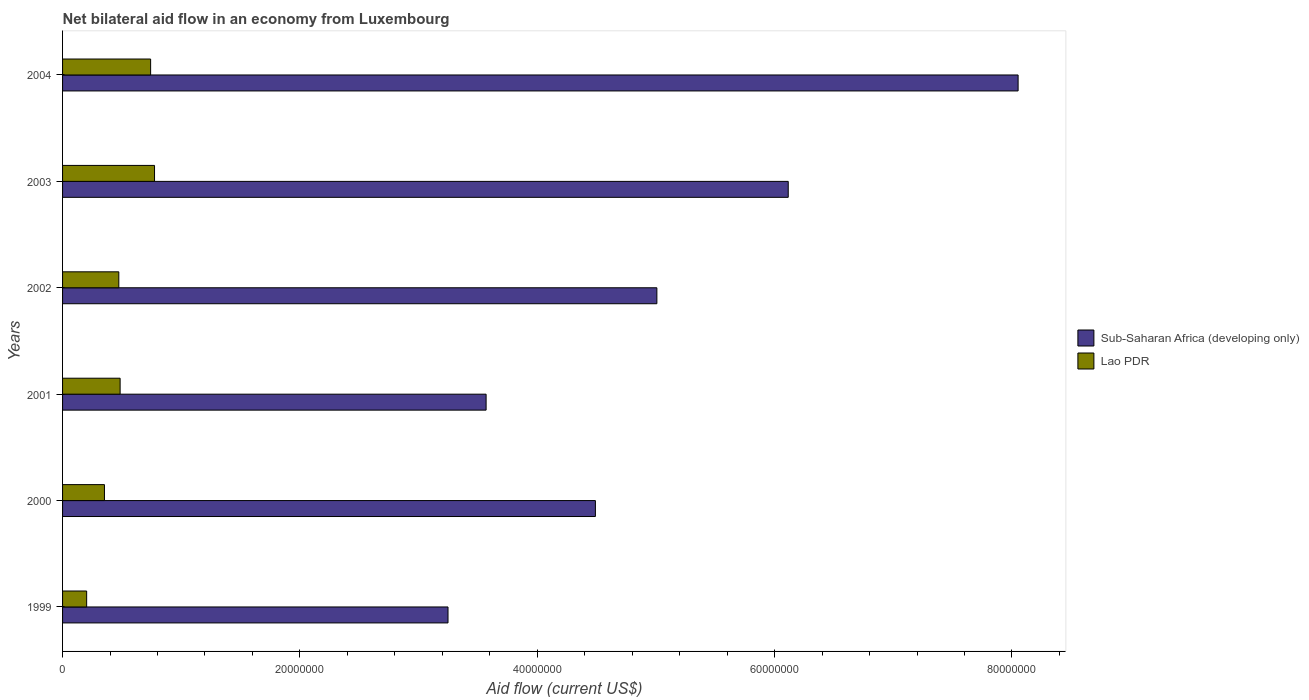How many different coloured bars are there?
Ensure brevity in your answer.  2. Are the number of bars on each tick of the Y-axis equal?
Make the answer very short. Yes. How many bars are there on the 3rd tick from the bottom?
Offer a very short reply. 2. What is the label of the 3rd group of bars from the top?
Your answer should be compact. 2002. In how many cases, is the number of bars for a given year not equal to the number of legend labels?
Provide a short and direct response. 0. What is the net bilateral aid flow in Sub-Saharan Africa (developing only) in 2001?
Keep it short and to the point. 3.57e+07. Across all years, what is the maximum net bilateral aid flow in Lao PDR?
Offer a very short reply. 7.75e+06. Across all years, what is the minimum net bilateral aid flow in Sub-Saharan Africa (developing only)?
Make the answer very short. 3.25e+07. What is the total net bilateral aid flow in Sub-Saharan Africa (developing only) in the graph?
Your answer should be very brief. 3.05e+08. What is the difference between the net bilateral aid flow in Sub-Saharan Africa (developing only) in 2000 and that in 2003?
Offer a terse response. -1.62e+07. What is the difference between the net bilateral aid flow in Sub-Saharan Africa (developing only) in 1999 and the net bilateral aid flow in Lao PDR in 2003?
Provide a succinct answer. 2.47e+07. What is the average net bilateral aid flow in Lao PDR per year?
Your answer should be very brief. 5.05e+06. In the year 2004, what is the difference between the net bilateral aid flow in Sub-Saharan Africa (developing only) and net bilateral aid flow in Lao PDR?
Provide a succinct answer. 7.31e+07. In how many years, is the net bilateral aid flow in Lao PDR greater than 32000000 US$?
Make the answer very short. 0. What is the ratio of the net bilateral aid flow in Sub-Saharan Africa (developing only) in 1999 to that in 2004?
Give a very brief answer. 0.4. Is the net bilateral aid flow in Lao PDR in 2001 less than that in 2004?
Provide a short and direct response. Yes. What is the difference between the highest and the second highest net bilateral aid flow in Sub-Saharan Africa (developing only)?
Your response must be concise. 1.94e+07. What is the difference between the highest and the lowest net bilateral aid flow in Sub-Saharan Africa (developing only)?
Keep it short and to the point. 4.80e+07. Is the sum of the net bilateral aid flow in Sub-Saharan Africa (developing only) in 2001 and 2002 greater than the maximum net bilateral aid flow in Lao PDR across all years?
Your answer should be very brief. Yes. What does the 1st bar from the top in 1999 represents?
Keep it short and to the point. Lao PDR. What does the 2nd bar from the bottom in 2000 represents?
Your answer should be compact. Lao PDR. How many bars are there?
Provide a succinct answer. 12. What is the difference between two consecutive major ticks on the X-axis?
Make the answer very short. 2.00e+07. Does the graph contain grids?
Keep it short and to the point. No. Where does the legend appear in the graph?
Keep it short and to the point. Center right. How many legend labels are there?
Your answer should be very brief. 2. How are the legend labels stacked?
Offer a terse response. Vertical. What is the title of the graph?
Your answer should be very brief. Net bilateral aid flow in an economy from Luxembourg. Does "Cyprus" appear as one of the legend labels in the graph?
Keep it short and to the point. No. What is the label or title of the Y-axis?
Ensure brevity in your answer.  Years. What is the Aid flow (current US$) in Sub-Saharan Africa (developing only) in 1999?
Your answer should be very brief. 3.25e+07. What is the Aid flow (current US$) in Lao PDR in 1999?
Provide a succinct answer. 2.03e+06. What is the Aid flow (current US$) in Sub-Saharan Africa (developing only) in 2000?
Give a very brief answer. 4.49e+07. What is the Aid flow (current US$) of Lao PDR in 2000?
Keep it short and to the point. 3.53e+06. What is the Aid flow (current US$) in Sub-Saharan Africa (developing only) in 2001?
Give a very brief answer. 3.57e+07. What is the Aid flow (current US$) in Lao PDR in 2001?
Offer a terse response. 4.85e+06. What is the Aid flow (current US$) in Sub-Saharan Africa (developing only) in 2002?
Offer a terse response. 5.01e+07. What is the Aid flow (current US$) of Lao PDR in 2002?
Your answer should be compact. 4.74e+06. What is the Aid flow (current US$) in Sub-Saharan Africa (developing only) in 2003?
Give a very brief answer. 6.12e+07. What is the Aid flow (current US$) of Lao PDR in 2003?
Your answer should be very brief. 7.75e+06. What is the Aid flow (current US$) in Sub-Saharan Africa (developing only) in 2004?
Provide a short and direct response. 8.05e+07. What is the Aid flow (current US$) in Lao PDR in 2004?
Provide a succinct answer. 7.42e+06. Across all years, what is the maximum Aid flow (current US$) in Sub-Saharan Africa (developing only)?
Your answer should be very brief. 8.05e+07. Across all years, what is the maximum Aid flow (current US$) in Lao PDR?
Offer a very short reply. 7.75e+06. Across all years, what is the minimum Aid flow (current US$) of Sub-Saharan Africa (developing only)?
Ensure brevity in your answer.  3.25e+07. Across all years, what is the minimum Aid flow (current US$) of Lao PDR?
Provide a short and direct response. 2.03e+06. What is the total Aid flow (current US$) of Sub-Saharan Africa (developing only) in the graph?
Give a very brief answer. 3.05e+08. What is the total Aid flow (current US$) in Lao PDR in the graph?
Your answer should be very brief. 3.03e+07. What is the difference between the Aid flow (current US$) of Sub-Saharan Africa (developing only) in 1999 and that in 2000?
Your answer should be very brief. -1.24e+07. What is the difference between the Aid flow (current US$) in Lao PDR in 1999 and that in 2000?
Keep it short and to the point. -1.50e+06. What is the difference between the Aid flow (current US$) in Sub-Saharan Africa (developing only) in 1999 and that in 2001?
Your response must be concise. -3.21e+06. What is the difference between the Aid flow (current US$) in Lao PDR in 1999 and that in 2001?
Provide a succinct answer. -2.82e+06. What is the difference between the Aid flow (current US$) of Sub-Saharan Africa (developing only) in 1999 and that in 2002?
Your answer should be very brief. -1.76e+07. What is the difference between the Aid flow (current US$) in Lao PDR in 1999 and that in 2002?
Your response must be concise. -2.71e+06. What is the difference between the Aid flow (current US$) in Sub-Saharan Africa (developing only) in 1999 and that in 2003?
Keep it short and to the point. -2.87e+07. What is the difference between the Aid flow (current US$) in Lao PDR in 1999 and that in 2003?
Your response must be concise. -5.72e+06. What is the difference between the Aid flow (current US$) in Sub-Saharan Africa (developing only) in 1999 and that in 2004?
Offer a very short reply. -4.80e+07. What is the difference between the Aid flow (current US$) in Lao PDR in 1999 and that in 2004?
Your answer should be compact. -5.39e+06. What is the difference between the Aid flow (current US$) in Sub-Saharan Africa (developing only) in 2000 and that in 2001?
Offer a terse response. 9.21e+06. What is the difference between the Aid flow (current US$) in Lao PDR in 2000 and that in 2001?
Provide a short and direct response. -1.32e+06. What is the difference between the Aid flow (current US$) in Sub-Saharan Africa (developing only) in 2000 and that in 2002?
Give a very brief answer. -5.18e+06. What is the difference between the Aid flow (current US$) in Lao PDR in 2000 and that in 2002?
Make the answer very short. -1.21e+06. What is the difference between the Aid flow (current US$) in Sub-Saharan Africa (developing only) in 2000 and that in 2003?
Offer a very short reply. -1.62e+07. What is the difference between the Aid flow (current US$) in Lao PDR in 2000 and that in 2003?
Your answer should be compact. -4.22e+06. What is the difference between the Aid flow (current US$) in Sub-Saharan Africa (developing only) in 2000 and that in 2004?
Ensure brevity in your answer.  -3.56e+07. What is the difference between the Aid flow (current US$) in Lao PDR in 2000 and that in 2004?
Your answer should be very brief. -3.89e+06. What is the difference between the Aid flow (current US$) in Sub-Saharan Africa (developing only) in 2001 and that in 2002?
Your answer should be compact. -1.44e+07. What is the difference between the Aid flow (current US$) of Lao PDR in 2001 and that in 2002?
Provide a short and direct response. 1.10e+05. What is the difference between the Aid flow (current US$) in Sub-Saharan Africa (developing only) in 2001 and that in 2003?
Give a very brief answer. -2.55e+07. What is the difference between the Aid flow (current US$) of Lao PDR in 2001 and that in 2003?
Make the answer very short. -2.90e+06. What is the difference between the Aid flow (current US$) of Sub-Saharan Africa (developing only) in 2001 and that in 2004?
Offer a terse response. -4.48e+07. What is the difference between the Aid flow (current US$) in Lao PDR in 2001 and that in 2004?
Your response must be concise. -2.57e+06. What is the difference between the Aid flow (current US$) in Sub-Saharan Africa (developing only) in 2002 and that in 2003?
Your response must be concise. -1.11e+07. What is the difference between the Aid flow (current US$) in Lao PDR in 2002 and that in 2003?
Provide a short and direct response. -3.01e+06. What is the difference between the Aid flow (current US$) of Sub-Saharan Africa (developing only) in 2002 and that in 2004?
Offer a terse response. -3.04e+07. What is the difference between the Aid flow (current US$) in Lao PDR in 2002 and that in 2004?
Offer a terse response. -2.68e+06. What is the difference between the Aid flow (current US$) of Sub-Saharan Africa (developing only) in 2003 and that in 2004?
Your answer should be compact. -1.94e+07. What is the difference between the Aid flow (current US$) in Lao PDR in 2003 and that in 2004?
Keep it short and to the point. 3.30e+05. What is the difference between the Aid flow (current US$) of Sub-Saharan Africa (developing only) in 1999 and the Aid flow (current US$) of Lao PDR in 2000?
Offer a very short reply. 2.90e+07. What is the difference between the Aid flow (current US$) in Sub-Saharan Africa (developing only) in 1999 and the Aid flow (current US$) in Lao PDR in 2001?
Ensure brevity in your answer.  2.76e+07. What is the difference between the Aid flow (current US$) in Sub-Saharan Africa (developing only) in 1999 and the Aid flow (current US$) in Lao PDR in 2002?
Provide a short and direct response. 2.77e+07. What is the difference between the Aid flow (current US$) of Sub-Saharan Africa (developing only) in 1999 and the Aid flow (current US$) of Lao PDR in 2003?
Offer a very short reply. 2.47e+07. What is the difference between the Aid flow (current US$) in Sub-Saharan Africa (developing only) in 1999 and the Aid flow (current US$) in Lao PDR in 2004?
Make the answer very short. 2.51e+07. What is the difference between the Aid flow (current US$) in Sub-Saharan Africa (developing only) in 2000 and the Aid flow (current US$) in Lao PDR in 2001?
Offer a terse response. 4.00e+07. What is the difference between the Aid flow (current US$) in Sub-Saharan Africa (developing only) in 2000 and the Aid flow (current US$) in Lao PDR in 2002?
Ensure brevity in your answer.  4.02e+07. What is the difference between the Aid flow (current US$) of Sub-Saharan Africa (developing only) in 2000 and the Aid flow (current US$) of Lao PDR in 2003?
Make the answer very short. 3.72e+07. What is the difference between the Aid flow (current US$) of Sub-Saharan Africa (developing only) in 2000 and the Aid flow (current US$) of Lao PDR in 2004?
Provide a short and direct response. 3.75e+07. What is the difference between the Aid flow (current US$) in Sub-Saharan Africa (developing only) in 2001 and the Aid flow (current US$) in Lao PDR in 2002?
Ensure brevity in your answer.  3.10e+07. What is the difference between the Aid flow (current US$) of Sub-Saharan Africa (developing only) in 2001 and the Aid flow (current US$) of Lao PDR in 2003?
Provide a short and direct response. 2.79e+07. What is the difference between the Aid flow (current US$) in Sub-Saharan Africa (developing only) in 2001 and the Aid flow (current US$) in Lao PDR in 2004?
Ensure brevity in your answer.  2.83e+07. What is the difference between the Aid flow (current US$) of Sub-Saharan Africa (developing only) in 2002 and the Aid flow (current US$) of Lao PDR in 2003?
Offer a terse response. 4.23e+07. What is the difference between the Aid flow (current US$) of Sub-Saharan Africa (developing only) in 2002 and the Aid flow (current US$) of Lao PDR in 2004?
Provide a short and direct response. 4.27e+07. What is the difference between the Aid flow (current US$) in Sub-Saharan Africa (developing only) in 2003 and the Aid flow (current US$) in Lao PDR in 2004?
Your answer should be compact. 5.37e+07. What is the average Aid flow (current US$) of Sub-Saharan Africa (developing only) per year?
Make the answer very short. 5.08e+07. What is the average Aid flow (current US$) in Lao PDR per year?
Your answer should be very brief. 5.05e+06. In the year 1999, what is the difference between the Aid flow (current US$) in Sub-Saharan Africa (developing only) and Aid flow (current US$) in Lao PDR?
Keep it short and to the point. 3.04e+07. In the year 2000, what is the difference between the Aid flow (current US$) of Sub-Saharan Africa (developing only) and Aid flow (current US$) of Lao PDR?
Keep it short and to the point. 4.14e+07. In the year 2001, what is the difference between the Aid flow (current US$) of Sub-Saharan Africa (developing only) and Aid flow (current US$) of Lao PDR?
Make the answer very short. 3.08e+07. In the year 2002, what is the difference between the Aid flow (current US$) in Sub-Saharan Africa (developing only) and Aid flow (current US$) in Lao PDR?
Provide a short and direct response. 4.53e+07. In the year 2003, what is the difference between the Aid flow (current US$) of Sub-Saharan Africa (developing only) and Aid flow (current US$) of Lao PDR?
Give a very brief answer. 5.34e+07. In the year 2004, what is the difference between the Aid flow (current US$) of Sub-Saharan Africa (developing only) and Aid flow (current US$) of Lao PDR?
Provide a succinct answer. 7.31e+07. What is the ratio of the Aid flow (current US$) of Sub-Saharan Africa (developing only) in 1999 to that in 2000?
Your response must be concise. 0.72. What is the ratio of the Aid flow (current US$) in Lao PDR in 1999 to that in 2000?
Provide a succinct answer. 0.58. What is the ratio of the Aid flow (current US$) in Sub-Saharan Africa (developing only) in 1999 to that in 2001?
Offer a terse response. 0.91. What is the ratio of the Aid flow (current US$) of Lao PDR in 1999 to that in 2001?
Provide a succinct answer. 0.42. What is the ratio of the Aid flow (current US$) of Sub-Saharan Africa (developing only) in 1999 to that in 2002?
Provide a succinct answer. 0.65. What is the ratio of the Aid flow (current US$) in Lao PDR in 1999 to that in 2002?
Provide a short and direct response. 0.43. What is the ratio of the Aid flow (current US$) in Sub-Saharan Africa (developing only) in 1999 to that in 2003?
Your response must be concise. 0.53. What is the ratio of the Aid flow (current US$) of Lao PDR in 1999 to that in 2003?
Make the answer very short. 0.26. What is the ratio of the Aid flow (current US$) of Sub-Saharan Africa (developing only) in 1999 to that in 2004?
Keep it short and to the point. 0.4. What is the ratio of the Aid flow (current US$) in Lao PDR in 1999 to that in 2004?
Offer a terse response. 0.27. What is the ratio of the Aid flow (current US$) of Sub-Saharan Africa (developing only) in 2000 to that in 2001?
Make the answer very short. 1.26. What is the ratio of the Aid flow (current US$) in Lao PDR in 2000 to that in 2001?
Your answer should be very brief. 0.73. What is the ratio of the Aid flow (current US$) of Sub-Saharan Africa (developing only) in 2000 to that in 2002?
Keep it short and to the point. 0.9. What is the ratio of the Aid flow (current US$) of Lao PDR in 2000 to that in 2002?
Make the answer very short. 0.74. What is the ratio of the Aid flow (current US$) of Sub-Saharan Africa (developing only) in 2000 to that in 2003?
Offer a very short reply. 0.73. What is the ratio of the Aid flow (current US$) in Lao PDR in 2000 to that in 2003?
Offer a very short reply. 0.46. What is the ratio of the Aid flow (current US$) in Sub-Saharan Africa (developing only) in 2000 to that in 2004?
Provide a succinct answer. 0.56. What is the ratio of the Aid flow (current US$) in Lao PDR in 2000 to that in 2004?
Your response must be concise. 0.48. What is the ratio of the Aid flow (current US$) of Sub-Saharan Africa (developing only) in 2001 to that in 2002?
Keep it short and to the point. 0.71. What is the ratio of the Aid flow (current US$) in Lao PDR in 2001 to that in 2002?
Offer a very short reply. 1.02. What is the ratio of the Aid flow (current US$) in Sub-Saharan Africa (developing only) in 2001 to that in 2003?
Offer a terse response. 0.58. What is the ratio of the Aid flow (current US$) of Lao PDR in 2001 to that in 2003?
Keep it short and to the point. 0.63. What is the ratio of the Aid flow (current US$) in Sub-Saharan Africa (developing only) in 2001 to that in 2004?
Provide a succinct answer. 0.44. What is the ratio of the Aid flow (current US$) of Lao PDR in 2001 to that in 2004?
Ensure brevity in your answer.  0.65. What is the ratio of the Aid flow (current US$) in Sub-Saharan Africa (developing only) in 2002 to that in 2003?
Offer a terse response. 0.82. What is the ratio of the Aid flow (current US$) of Lao PDR in 2002 to that in 2003?
Your response must be concise. 0.61. What is the ratio of the Aid flow (current US$) in Sub-Saharan Africa (developing only) in 2002 to that in 2004?
Your response must be concise. 0.62. What is the ratio of the Aid flow (current US$) of Lao PDR in 2002 to that in 2004?
Your answer should be compact. 0.64. What is the ratio of the Aid flow (current US$) of Sub-Saharan Africa (developing only) in 2003 to that in 2004?
Provide a short and direct response. 0.76. What is the ratio of the Aid flow (current US$) in Lao PDR in 2003 to that in 2004?
Your response must be concise. 1.04. What is the difference between the highest and the second highest Aid flow (current US$) of Sub-Saharan Africa (developing only)?
Your response must be concise. 1.94e+07. What is the difference between the highest and the lowest Aid flow (current US$) of Sub-Saharan Africa (developing only)?
Your response must be concise. 4.80e+07. What is the difference between the highest and the lowest Aid flow (current US$) in Lao PDR?
Offer a very short reply. 5.72e+06. 